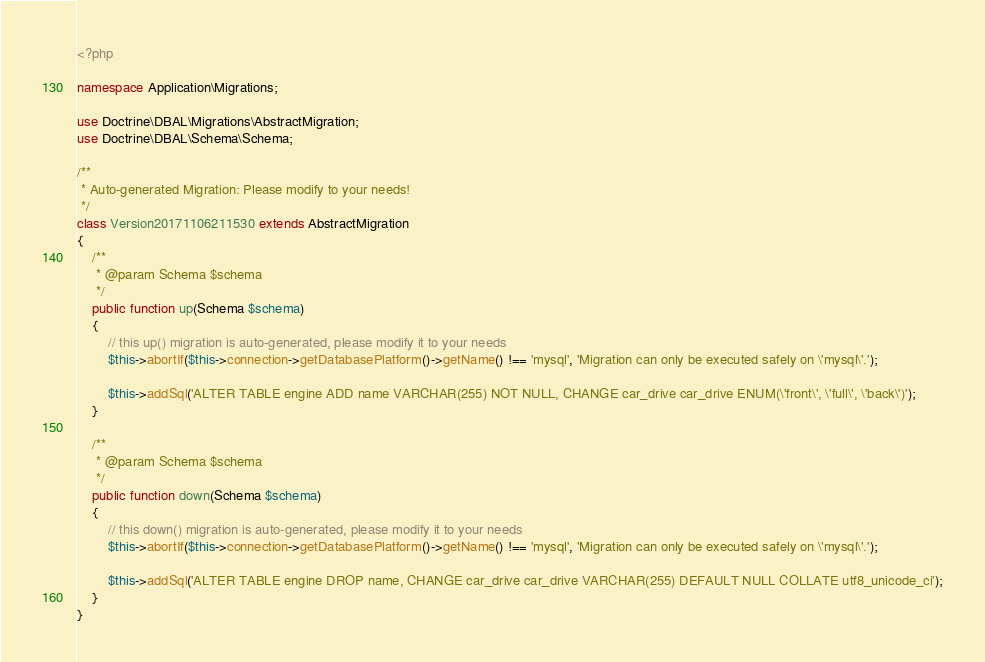Convert code to text. <code><loc_0><loc_0><loc_500><loc_500><_PHP_><?php

namespace Application\Migrations;

use Doctrine\DBAL\Migrations\AbstractMigration;
use Doctrine\DBAL\Schema\Schema;

/**
 * Auto-generated Migration: Please modify to your needs!
 */
class Version20171106211530 extends AbstractMigration
{
    /**
     * @param Schema $schema
     */
    public function up(Schema $schema)
    {
        // this up() migration is auto-generated, please modify it to your needs
        $this->abortIf($this->connection->getDatabasePlatform()->getName() !== 'mysql', 'Migration can only be executed safely on \'mysql\'.');

        $this->addSql('ALTER TABLE engine ADD name VARCHAR(255) NOT NULL, CHANGE car_drive car_drive ENUM(\'front\', \'full\', \'back\')');
    }

    /**
     * @param Schema $schema
     */
    public function down(Schema $schema)
    {
        // this down() migration is auto-generated, please modify it to your needs
        $this->abortIf($this->connection->getDatabasePlatform()->getName() !== 'mysql', 'Migration can only be executed safely on \'mysql\'.');

        $this->addSql('ALTER TABLE engine DROP name, CHANGE car_drive car_drive VARCHAR(255) DEFAULT NULL COLLATE utf8_unicode_ci');
    }
}
</code> 